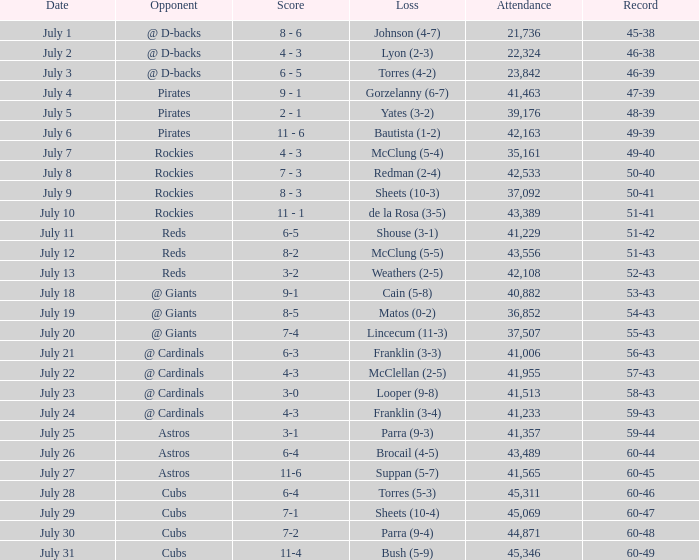What's the attendance of the game where there was a Loss of Yates (3-2)? 39176.0. 